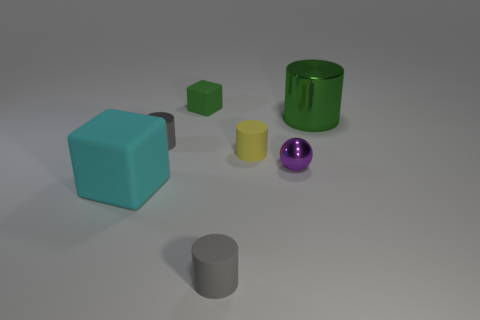Is the cyan matte thing the same shape as the small green thing?
Your response must be concise. Yes. How many large things are either yellow rubber things or green things?
Provide a short and direct response. 1. There is a tiny cylinder that is the same material as the large green cylinder; what is its color?
Offer a very short reply. Gray. How many green things are the same material as the ball?
Keep it short and to the point. 1. There is a rubber block behind the small gray metallic cylinder; is it the same size as the cube on the left side of the tiny metallic cylinder?
Ensure brevity in your answer.  No. There is a large object that is behind the tiny object that is to the left of the tiny cube; what is it made of?
Ensure brevity in your answer.  Metal. Is the number of tiny matte blocks that are in front of the cyan rubber block less than the number of green things left of the big shiny thing?
Your answer should be very brief. Yes. There is a large cylinder that is the same color as the tiny rubber cube; what is it made of?
Make the answer very short. Metal. Is there anything else that has the same shape as the small purple metal object?
Give a very brief answer. No. What is the material of the gray thing behind the big rubber block?
Give a very brief answer. Metal. 